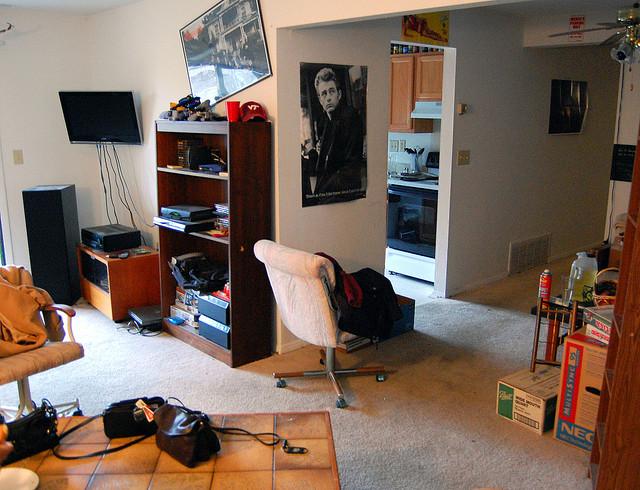Is James Dean in the room?
Write a very short answer. Yes. What color is the wall?
Keep it brief. White. Are there any boxes in the room?
Short answer required. Yes. 